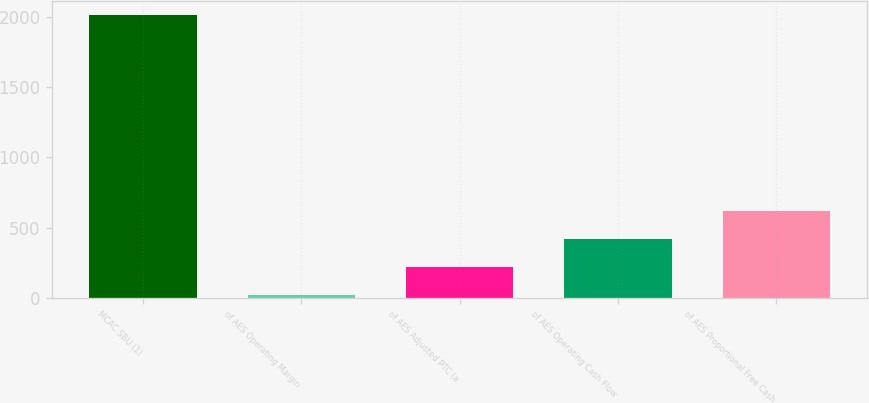<chart> <loc_0><loc_0><loc_500><loc_500><bar_chart><fcel>MCAC SBU (1)<fcel>of AES Operating Margin<fcel>of AES Adjusted PTC (a<fcel>of AES Operating Cash Flow<fcel>of AES Proportional Free Cash<nl><fcel>2015<fcel>19<fcel>218.6<fcel>418.2<fcel>617.8<nl></chart> 